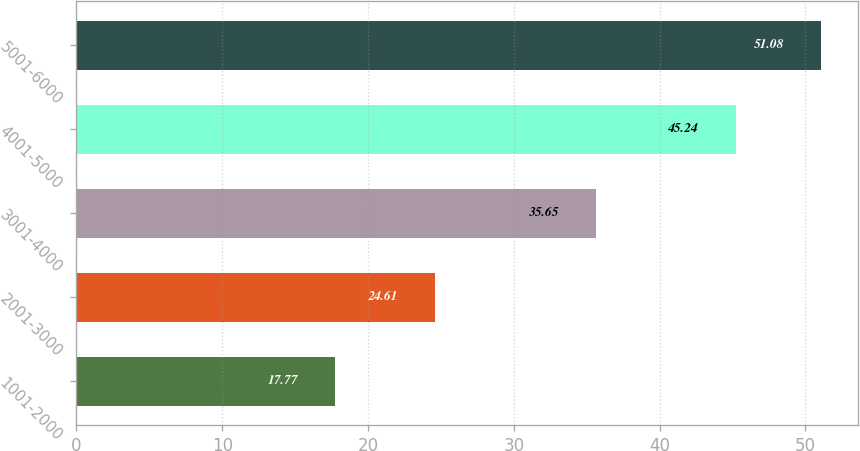Convert chart to OTSL. <chart><loc_0><loc_0><loc_500><loc_500><bar_chart><fcel>1001-2000<fcel>2001-3000<fcel>3001-4000<fcel>4001-5000<fcel>5001-6000<nl><fcel>17.77<fcel>24.61<fcel>35.65<fcel>45.24<fcel>51.08<nl></chart> 